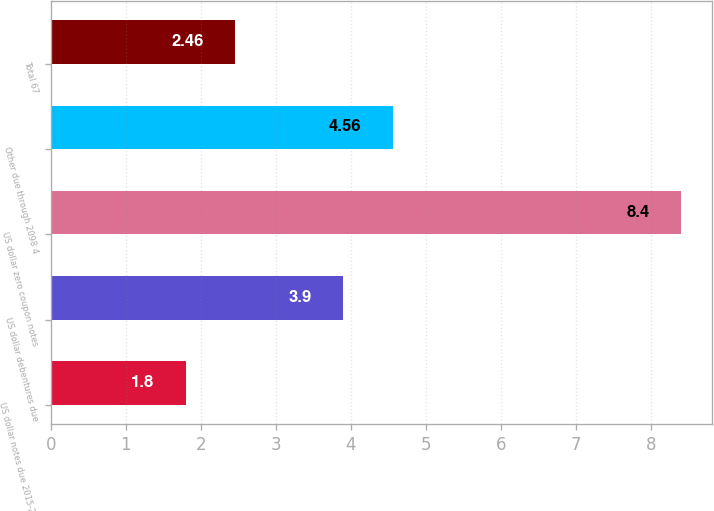Convert chart. <chart><loc_0><loc_0><loc_500><loc_500><bar_chart><fcel>US dollar notes due 2015-2093<fcel>US dollar debentures due<fcel>US dollar zero coupon notes<fcel>Other due through 2098 4<fcel>Total 67<nl><fcel>1.8<fcel>3.9<fcel>8.4<fcel>4.56<fcel>2.46<nl></chart> 